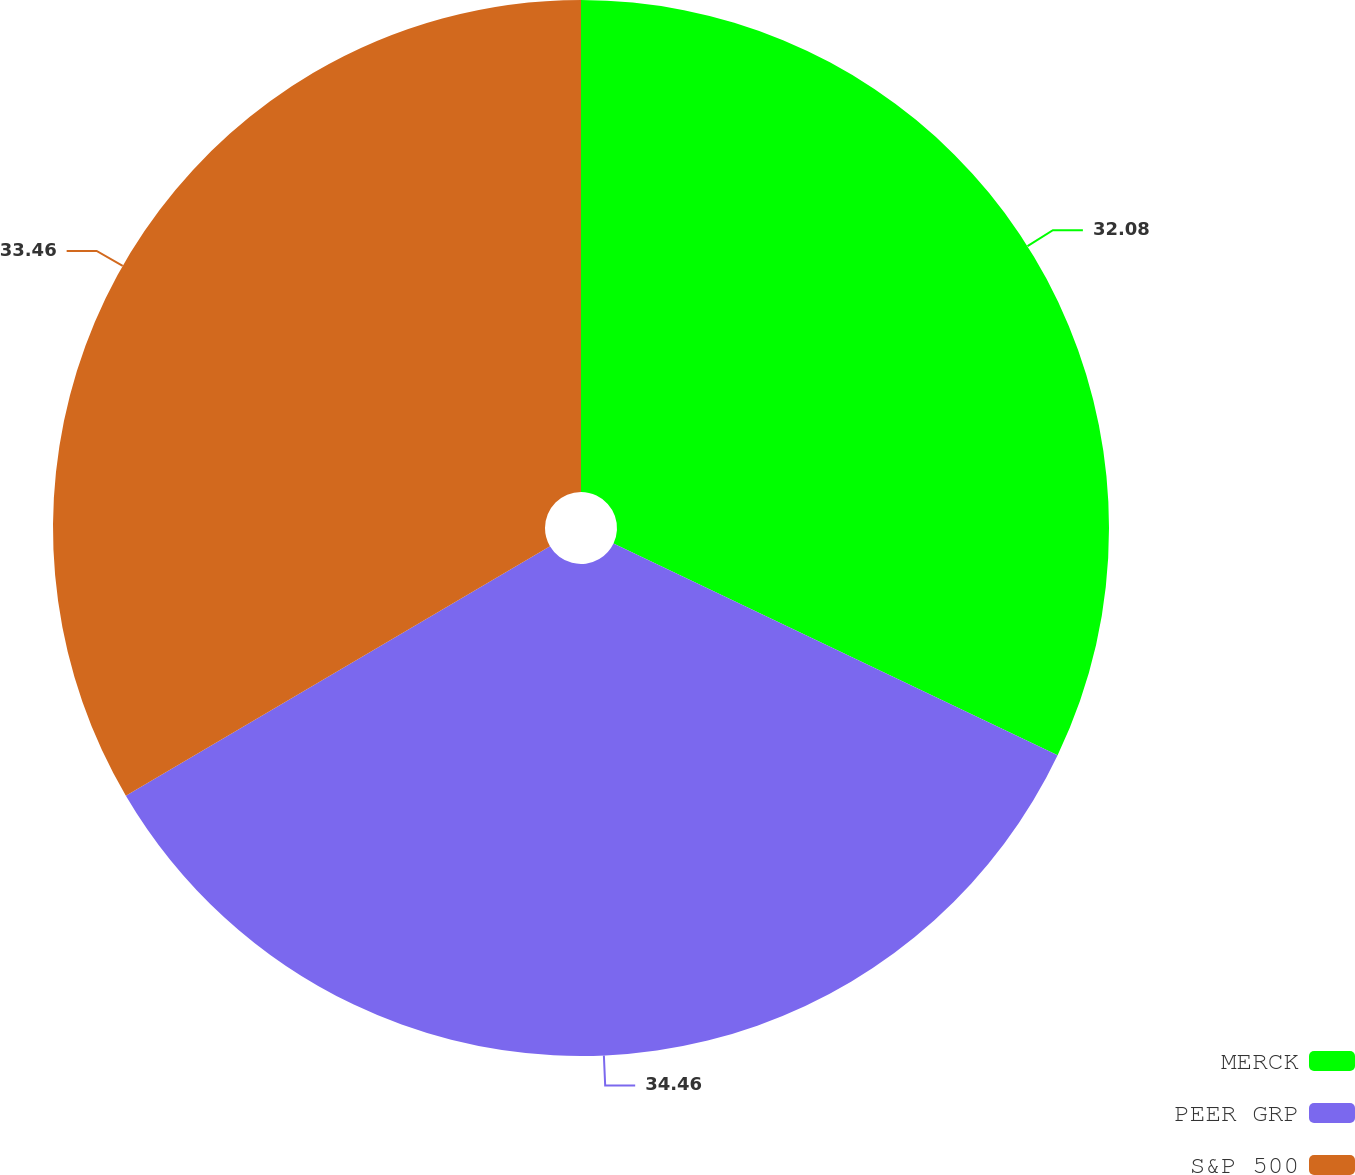Convert chart to OTSL. <chart><loc_0><loc_0><loc_500><loc_500><pie_chart><fcel>MERCK<fcel>PEER GRP<fcel>S&P 500<nl><fcel>32.08%<fcel>34.46%<fcel>33.46%<nl></chart> 